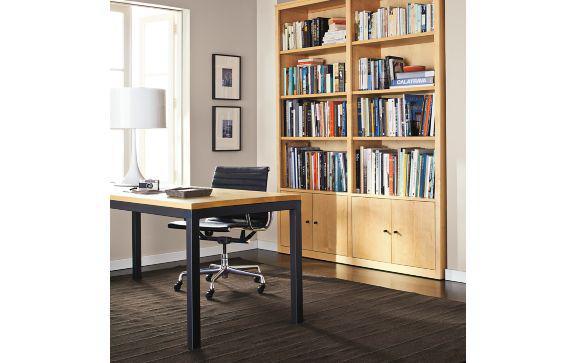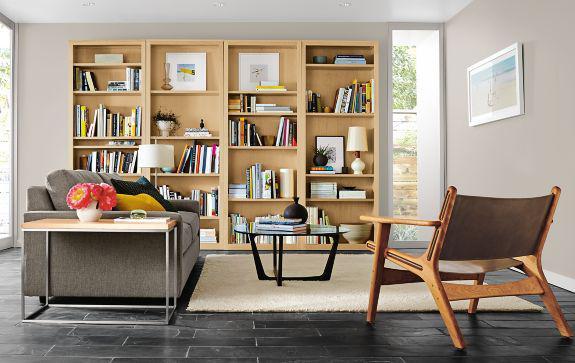The first image is the image on the left, the second image is the image on the right. Examine the images to the left and right. Is the description "A TV is sitting on a stand between two bookshelves." accurate? Answer yes or no. No. The first image is the image on the left, the second image is the image on the right. Assess this claim about the two images: "There is a television set in between two bookcases.". Correct or not? Answer yes or no. No. 